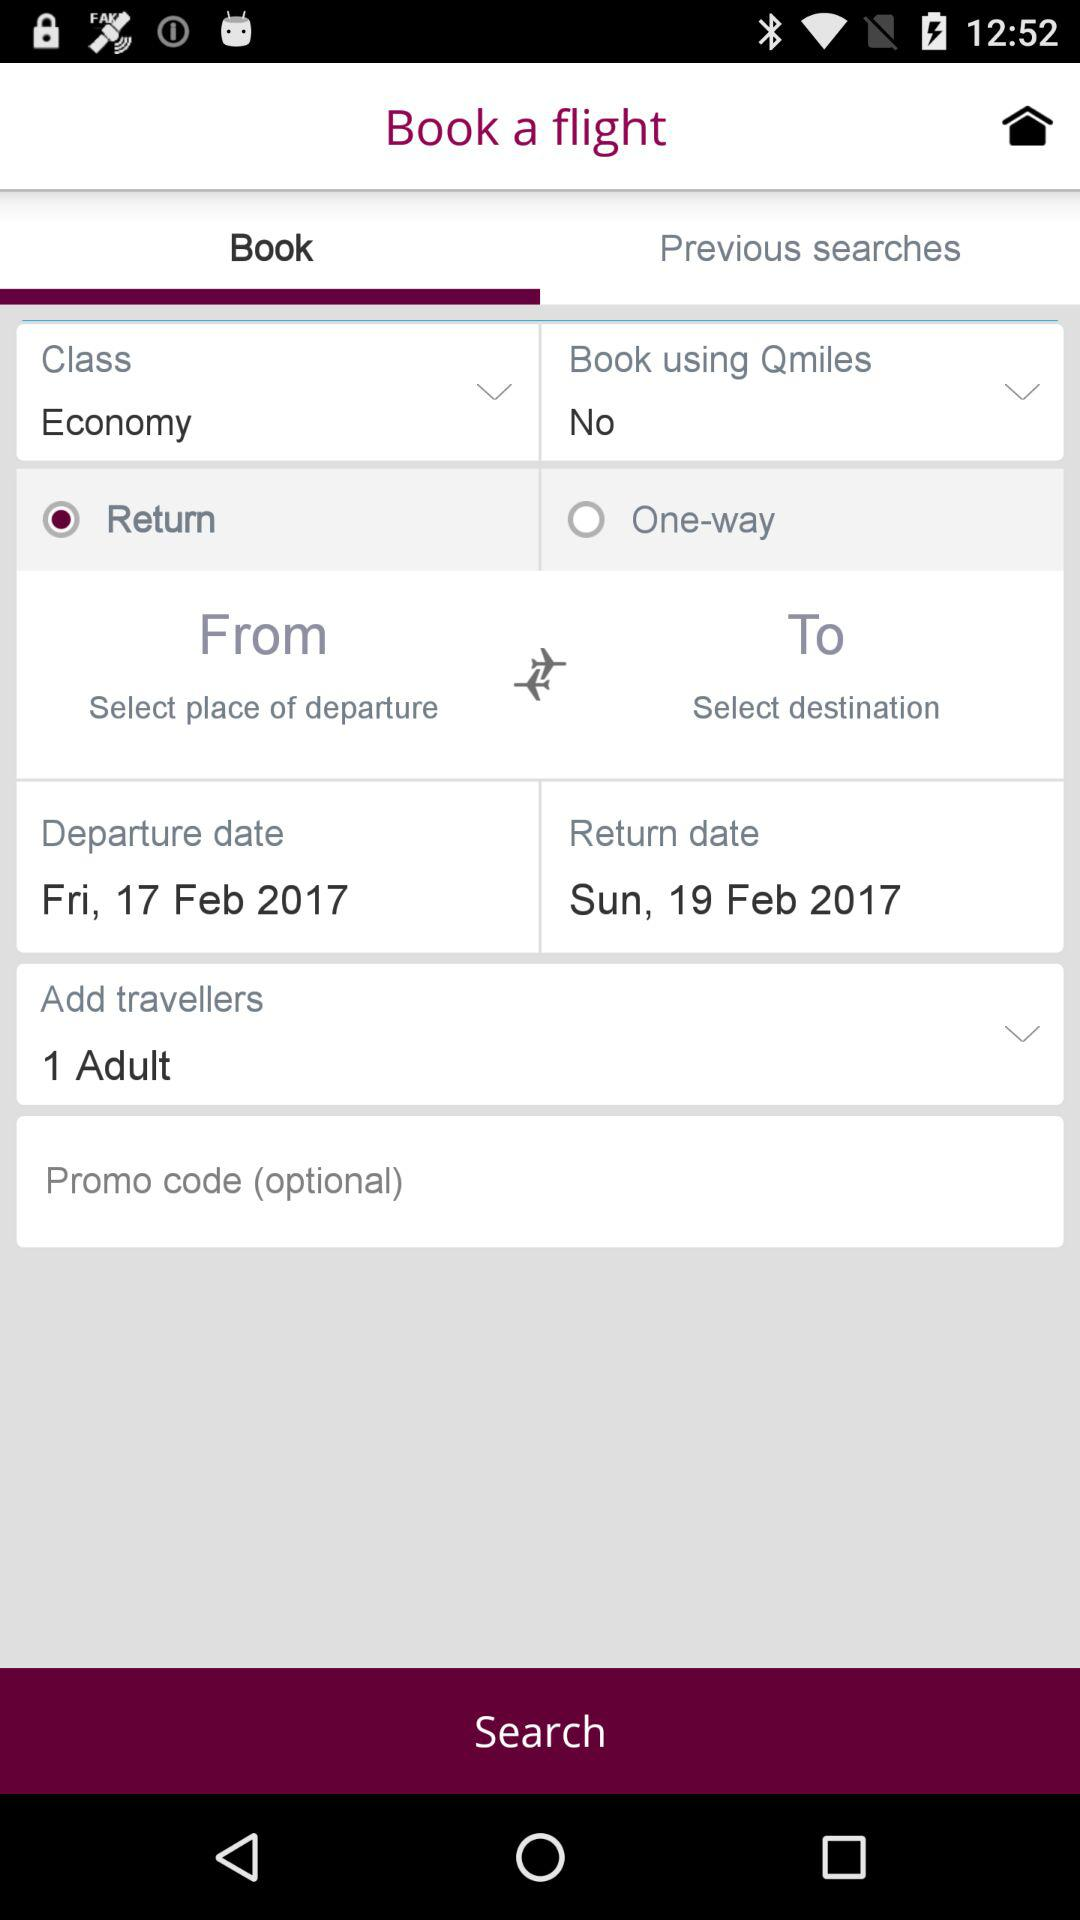Which type of flight ticket is selected? The selected type of flight ticket is "Return". 